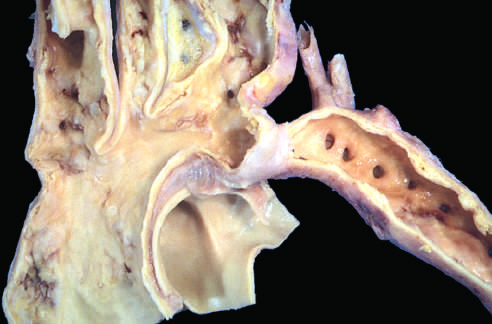when do such lesions manifest than preductal coarctations?
Answer the question using a single word or phrase. Later in life 